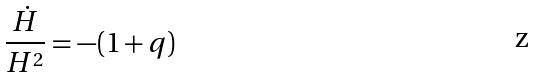<formula> <loc_0><loc_0><loc_500><loc_500>\frac { \dot { H } } { H ^ { 2 } } = - ( 1 + q )</formula> 